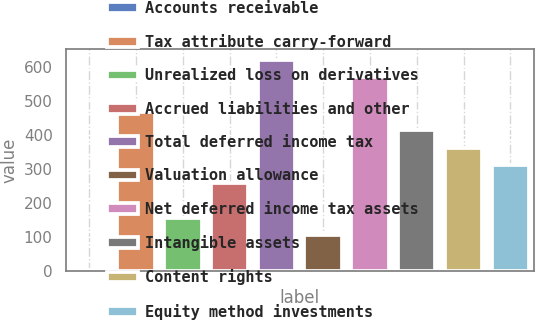Convert chart. <chart><loc_0><loc_0><loc_500><loc_500><bar_chart><fcel>Accounts receivable<fcel>Tax attribute carry-forward<fcel>Unrealized loss on derivatives<fcel>Accrued liabilities and other<fcel>Total deferred income tax<fcel>Valuation allowance<fcel>Net deferred income tax assets<fcel>Intangible assets<fcel>Content rights<fcel>Equity method investments<nl><fcel>2<fcel>466.4<fcel>156.8<fcel>260<fcel>621.2<fcel>105.2<fcel>569.6<fcel>414.8<fcel>363.2<fcel>311.6<nl></chart> 